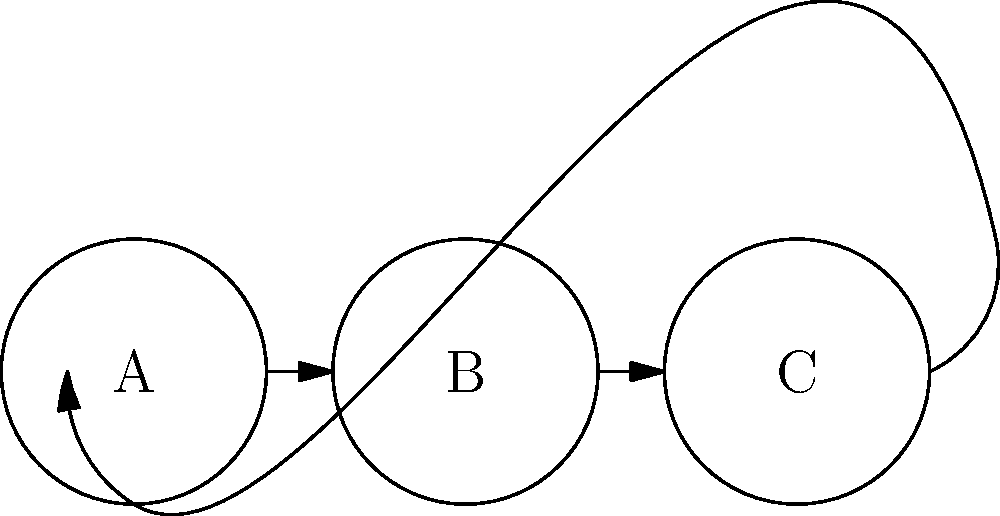As a mother who frequently shares baby product experiences, you've encountered a unique group theory problem involving baby food jars. Consider three types of baby food jars: A (pureed apples), B (mashed bananas), and C (carrot puree). The diagram shows how these jars can be combined and rearranged. If combining two jars always results in one of the three types, and the order matters, what is the order of this group? To determine the order of this group, we need to follow these steps:

1. Identify the elements: The elements of the group are A, B, and C.

2. Understand the operation: The operation is combining jars, where the order matters.

3. Check for closure: The diagram shows that combining any two jars always results in one of A, B, or C, satisfying closure.

4. Identify the identity element: Since combining with itself doesn't change a jar, each element is its own identity.

5. Check for associativity: This is assumed for this type of combination.

6. Find inverses: Each element is its own inverse, as shown by the arrows forming a cycle.

7. Count the number of elements: There are 3 elements in the group.

8. Consider possible orders:
   - Order 1: Only possible for the trivial group with one element.
   - Order 2: Not possible with 3 elements.
   - Order 3: Possible if the elements form a cycle, which they do in this case.

9. Confirm the cycle: A → B → C → A forms a complete cycle.

Therefore, the group has an order of 3, forming a cyclic group of order 3, often denoted as $C_3$ or $\mathbb{Z}_3$.
Answer: 3 